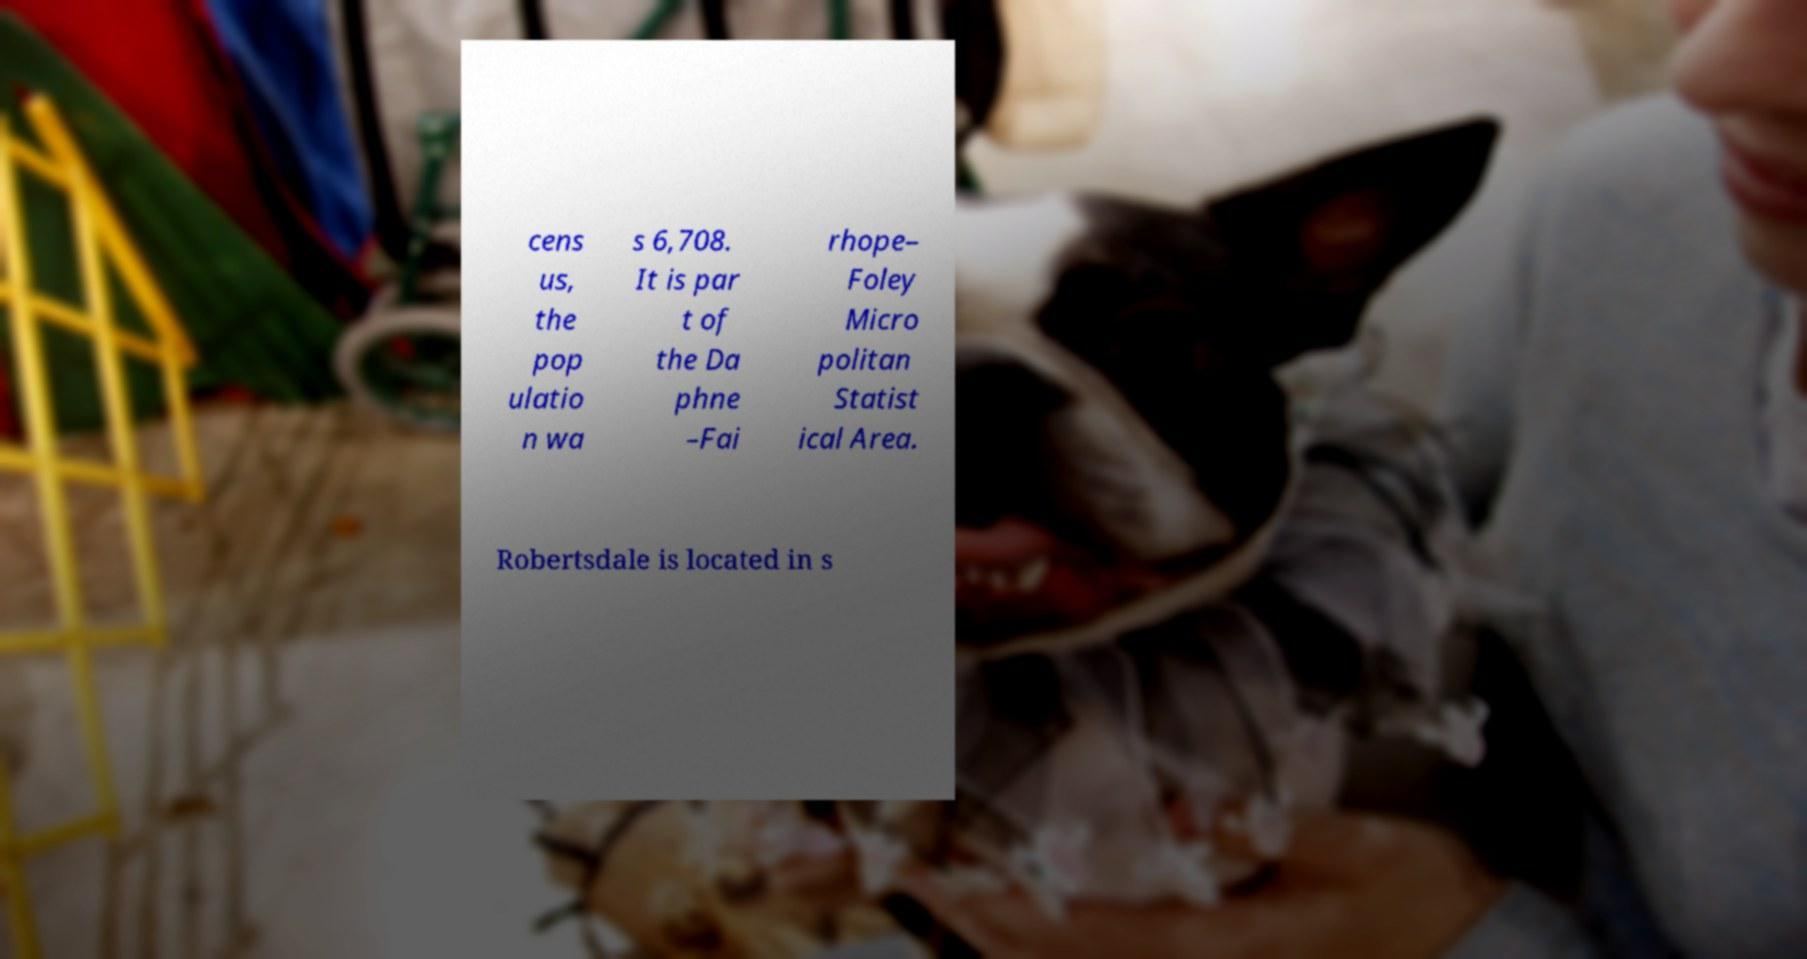There's text embedded in this image that I need extracted. Can you transcribe it verbatim? cens us, the pop ulatio n wa s 6,708. It is par t of the Da phne –Fai rhope– Foley Micro politan Statist ical Area. Robertsdale is located in s 